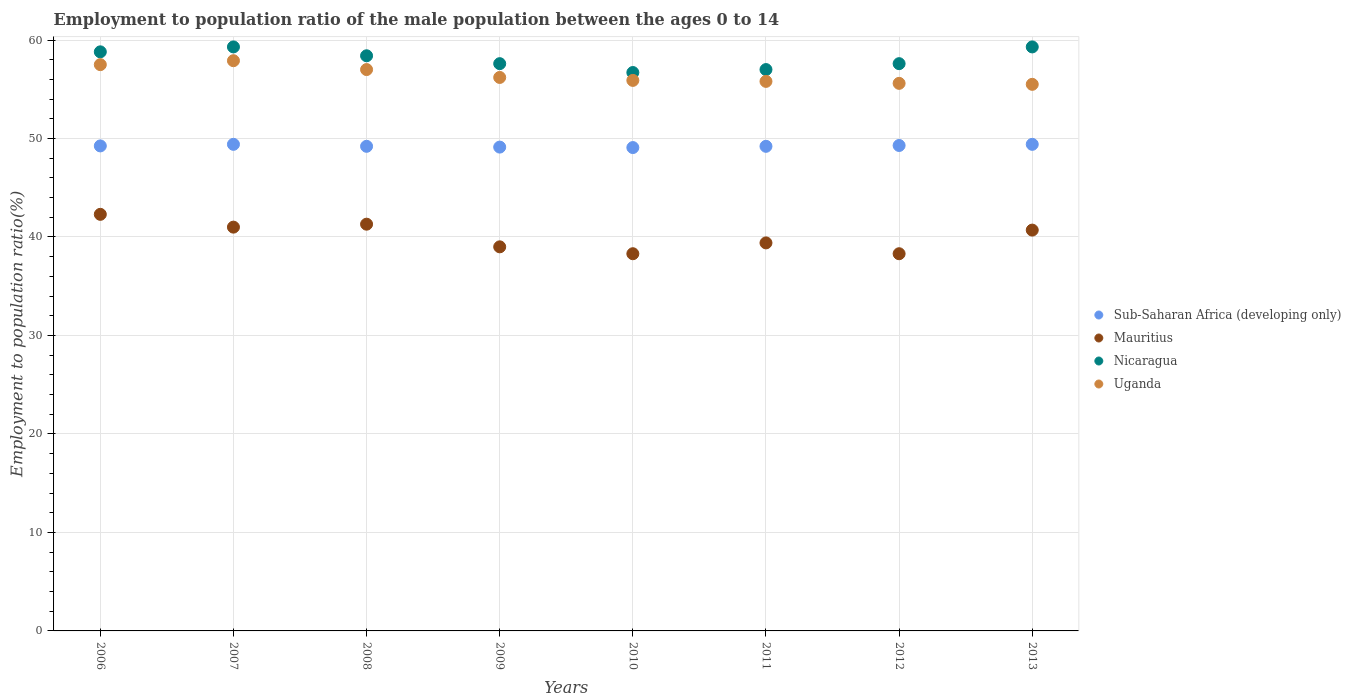Is the number of dotlines equal to the number of legend labels?
Provide a succinct answer. Yes. What is the employment to population ratio in Sub-Saharan Africa (developing only) in 2011?
Provide a short and direct response. 49.21. Across all years, what is the maximum employment to population ratio in Uganda?
Make the answer very short. 57.9. Across all years, what is the minimum employment to population ratio in Uganda?
Offer a terse response. 55.5. In which year was the employment to population ratio in Sub-Saharan Africa (developing only) maximum?
Make the answer very short. 2007. In which year was the employment to population ratio in Mauritius minimum?
Provide a short and direct response. 2010. What is the total employment to population ratio in Sub-Saharan Africa (developing only) in the graph?
Provide a short and direct response. 393.98. What is the difference between the employment to population ratio in Nicaragua in 2007 and that in 2012?
Make the answer very short. 1.7. What is the difference between the employment to population ratio in Uganda in 2010 and the employment to population ratio in Mauritius in 2008?
Provide a short and direct response. 14.6. What is the average employment to population ratio in Mauritius per year?
Your response must be concise. 40.04. In the year 2007, what is the difference between the employment to population ratio in Mauritius and employment to population ratio in Sub-Saharan Africa (developing only)?
Provide a short and direct response. -8.41. What is the ratio of the employment to population ratio in Nicaragua in 2009 to that in 2012?
Your answer should be very brief. 1. Is the employment to population ratio in Mauritius in 2008 less than that in 2013?
Your answer should be compact. No. What is the difference between the highest and the lowest employment to population ratio in Nicaragua?
Your answer should be very brief. 2.6. In how many years, is the employment to population ratio in Mauritius greater than the average employment to population ratio in Mauritius taken over all years?
Make the answer very short. 4. Is it the case that in every year, the sum of the employment to population ratio in Sub-Saharan Africa (developing only) and employment to population ratio in Uganda  is greater than the employment to population ratio in Mauritius?
Your answer should be compact. Yes. Does the employment to population ratio in Nicaragua monotonically increase over the years?
Provide a succinct answer. No. How many years are there in the graph?
Ensure brevity in your answer.  8. Does the graph contain any zero values?
Provide a succinct answer. No. Does the graph contain grids?
Your answer should be very brief. Yes. What is the title of the graph?
Offer a very short reply. Employment to population ratio of the male population between the ages 0 to 14. What is the label or title of the X-axis?
Your answer should be very brief. Years. What is the Employment to population ratio(%) of Sub-Saharan Africa (developing only) in 2006?
Give a very brief answer. 49.25. What is the Employment to population ratio(%) of Mauritius in 2006?
Keep it short and to the point. 42.3. What is the Employment to population ratio(%) in Nicaragua in 2006?
Offer a terse response. 58.8. What is the Employment to population ratio(%) in Uganda in 2006?
Ensure brevity in your answer.  57.5. What is the Employment to population ratio(%) in Sub-Saharan Africa (developing only) in 2007?
Give a very brief answer. 49.41. What is the Employment to population ratio(%) of Nicaragua in 2007?
Offer a very short reply. 59.3. What is the Employment to population ratio(%) of Uganda in 2007?
Give a very brief answer. 57.9. What is the Employment to population ratio(%) of Sub-Saharan Africa (developing only) in 2008?
Provide a short and direct response. 49.21. What is the Employment to population ratio(%) in Mauritius in 2008?
Ensure brevity in your answer.  41.3. What is the Employment to population ratio(%) of Nicaragua in 2008?
Offer a terse response. 58.4. What is the Employment to population ratio(%) of Uganda in 2008?
Your answer should be compact. 57. What is the Employment to population ratio(%) of Sub-Saharan Africa (developing only) in 2009?
Offer a terse response. 49.13. What is the Employment to population ratio(%) in Mauritius in 2009?
Your answer should be very brief. 39. What is the Employment to population ratio(%) of Nicaragua in 2009?
Your response must be concise. 57.6. What is the Employment to population ratio(%) of Uganda in 2009?
Your response must be concise. 56.2. What is the Employment to population ratio(%) of Sub-Saharan Africa (developing only) in 2010?
Give a very brief answer. 49.08. What is the Employment to population ratio(%) of Mauritius in 2010?
Your answer should be very brief. 38.3. What is the Employment to population ratio(%) of Nicaragua in 2010?
Ensure brevity in your answer.  56.7. What is the Employment to population ratio(%) in Uganda in 2010?
Make the answer very short. 55.9. What is the Employment to population ratio(%) in Sub-Saharan Africa (developing only) in 2011?
Provide a succinct answer. 49.21. What is the Employment to population ratio(%) of Mauritius in 2011?
Your response must be concise. 39.4. What is the Employment to population ratio(%) in Nicaragua in 2011?
Offer a very short reply. 57. What is the Employment to population ratio(%) in Uganda in 2011?
Your response must be concise. 55.8. What is the Employment to population ratio(%) in Sub-Saharan Africa (developing only) in 2012?
Keep it short and to the point. 49.29. What is the Employment to population ratio(%) of Mauritius in 2012?
Offer a terse response. 38.3. What is the Employment to population ratio(%) in Nicaragua in 2012?
Provide a succinct answer. 57.6. What is the Employment to population ratio(%) of Uganda in 2012?
Keep it short and to the point. 55.6. What is the Employment to population ratio(%) in Sub-Saharan Africa (developing only) in 2013?
Your response must be concise. 49.41. What is the Employment to population ratio(%) of Mauritius in 2013?
Keep it short and to the point. 40.7. What is the Employment to population ratio(%) in Nicaragua in 2013?
Your response must be concise. 59.3. What is the Employment to population ratio(%) in Uganda in 2013?
Your answer should be compact. 55.5. Across all years, what is the maximum Employment to population ratio(%) in Sub-Saharan Africa (developing only)?
Offer a very short reply. 49.41. Across all years, what is the maximum Employment to population ratio(%) of Mauritius?
Keep it short and to the point. 42.3. Across all years, what is the maximum Employment to population ratio(%) of Nicaragua?
Provide a succinct answer. 59.3. Across all years, what is the maximum Employment to population ratio(%) of Uganda?
Offer a very short reply. 57.9. Across all years, what is the minimum Employment to population ratio(%) in Sub-Saharan Africa (developing only)?
Make the answer very short. 49.08. Across all years, what is the minimum Employment to population ratio(%) of Mauritius?
Offer a terse response. 38.3. Across all years, what is the minimum Employment to population ratio(%) in Nicaragua?
Offer a very short reply. 56.7. Across all years, what is the minimum Employment to population ratio(%) of Uganda?
Keep it short and to the point. 55.5. What is the total Employment to population ratio(%) of Sub-Saharan Africa (developing only) in the graph?
Make the answer very short. 393.98. What is the total Employment to population ratio(%) of Mauritius in the graph?
Provide a succinct answer. 320.3. What is the total Employment to population ratio(%) of Nicaragua in the graph?
Your answer should be very brief. 464.7. What is the total Employment to population ratio(%) of Uganda in the graph?
Provide a succinct answer. 451.4. What is the difference between the Employment to population ratio(%) of Sub-Saharan Africa (developing only) in 2006 and that in 2007?
Make the answer very short. -0.16. What is the difference between the Employment to population ratio(%) of Nicaragua in 2006 and that in 2007?
Ensure brevity in your answer.  -0.5. What is the difference between the Employment to population ratio(%) of Sub-Saharan Africa (developing only) in 2006 and that in 2008?
Keep it short and to the point. 0.04. What is the difference between the Employment to population ratio(%) of Uganda in 2006 and that in 2008?
Give a very brief answer. 0.5. What is the difference between the Employment to population ratio(%) in Sub-Saharan Africa (developing only) in 2006 and that in 2009?
Make the answer very short. 0.12. What is the difference between the Employment to population ratio(%) of Mauritius in 2006 and that in 2009?
Provide a short and direct response. 3.3. What is the difference between the Employment to population ratio(%) in Uganda in 2006 and that in 2009?
Offer a terse response. 1.3. What is the difference between the Employment to population ratio(%) of Sub-Saharan Africa (developing only) in 2006 and that in 2010?
Keep it short and to the point. 0.17. What is the difference between the Employment to population ratio(%) of Mauritius in 2006 and that in 2010?
Your answer should be compact. 4. What is the difference between the Employment to population ratio(%) of Sub-Saharan Africa (developing only) in 2006 and that in 2011?
Offer a terse response. 0.04. What is the difference between the Employment to population ratio(%) of Mauritius in 2006 and that in 2011?
Provide a succinct answer. 2.9. What is the difference between the Employment to population ratio(%) in Nicaragua in 2006 and that in 2011?
Offer a very short reply. 1.8. What is the difference between the Employment to population ratio(%) of Sub-Saharan Africa (developing only) in 2006 and that in 2012?
Your answer should be compact. -0.04. What is the difference between the Employment to population ratio(%) of Mauritius in 2006 and that in 2012?
Your answer should be very brief. 4. What is the difference between the Employment to population ratio(%) of Sub-Saharan Africa (developing only) in 2006 and that in 2013?
Offer a very short reply. -0.16. What is the difference between the Employment to population ratio(%) of Uganda in 2006 and that in 2013?
Offer a very short reply. 2. What is the difference between the Employment to population ratio(%) of Sub-Saharan Africa (developing only) in 2007 and that in 2008?
Make the answer very short. 0.2. What is the difference between the Employment to population ratio(%) in Mauritius in 2007 and that in 2008?
Keep it short and to the point. -0.3. What is the difference between the Employment to population ratio(%) in Nicaragua in 2007 and that in 2008?
Offer a very short reply. 0.9. What is the difference between the Employment to population ratio(%) in Uganda in 2007 and that in 2008?
Offer a very short reply. 0.9. What is the difference between the Employment to population ratio(%) in Sub-Saharan Africa (developing only) in 2007 and that in 2009?
Your answer should be very brief. 0.28. What is the difference between the Employment to population ratio(%) in Sub-Saharan Africa (developing only) in 2007 and that in 2010?
Your answer should be very brief. 0.33. What is the difference between the Employment to population ratio(%) of Mauritius in 2007 and that in 2010?
Provide a short and direct response. 2.7. What is the difference between the Employment to population ratio(%) of Nicaragua in 2007 and that in 2010?
Your answer should be very brief. 2.6. What is the difference between the Employment to population ratio(%) of Sub-Saharan Africa (developing only) in 2007 and that in 2011?
Provide a succinct answer. 0.2. What is the difference between the Employment to population ratio(%) in Uganda in 2007 and that in 2011?
Offer a very short reply. 2.1. What is the difference between the Employment to population ratio(%) of Sub-Saharan Africa (developing only) in 2007 and that in 2012?
Provide a short and direct response. 0.12. What is the difference between the Employment to population ratio(%) of Mauritius in 2007 and that in 2012?
Provide a short and direct response. 2.7. What is the difference between the Employment to population ratio(%) of Nicaragua in 2007 and that in 2012?
Provide a succinct answer. 1.7. What is the difference between the Employment to population ratio(%) of Sub-Saharan Africa (developing only) in 2007 and that in 2013?
Give a very brief answer. 0. What is the difference between the Employment to population ratio(%) in Sub-Saharan Africa (developing only) in 2008 and that in 2009?
Your response must be concise. 0.08. What is the difference between the Employment to population ratio(%) of Mauritius in 2008 and that in 2009?
Offer a very short reply. 2.3. What is the difference between the Employment to population ratio(%) in Nicaragua in 2008 and that in 2009?
Make the answer very short. 0.8. What is the difference between the Employment to population ratio(%) of Sub-Saharan Africa (developing only) in 2008 and that in 2010?
Provide a succinct answer. 0.13. What is the difference between the Employment to population ratio(%) of Mauritius in 2008 and that in 2010?
Provide a succinct answer. 3. What is the difference between the Employment to population ratio(%) in Sub-Saharan Africa (developing only) in 2008 and that in 2011?
Keep it short and to the point. 0. What is the difference between the Employment to population ratio(%) of Mauritius in 2008 and that in 2011?
Keep it short and to the point. 1.9. What is the difference between the Employment to population ratio(%) of Nicaragua in 2008 and that in 2011?
Keep it short and to the point. 1.4. What is the difference between the Employment to population ratio(%) of Sub-Saharan Africa (developing only) in 2008 and that in 2012?
Offer a terse response. -0.08. What is the difference between the Employment to population ratio(%) in Sub-Saharan Africa (developing only) in 2008 and that in 2013?
Ensure brevity in your answer.  -0.2. What is the difference between the Employment to population ratio(%) in Mauritius in 2008 and that in 2013?
Provide a short and direct response. 0.6. What is the difference between the Employment to population ratio(%) in Nicaragua in 2008 and that in 2013?
Give a very brief answer. -0.9. What is the difference between the Employment to population ratio(%) in Uganda in 2008 and that in 2013?
Offer a very short reply. 1.5. What is the difference between the Employment to population ratio(%) in Sub-Saharan Africa (developing only) in 2009 and that in 2010?
Ensure brevity in your answer.  0.05. What is the difference between the Employment to population ratio(%) of Mauritius in 2009 and that in 2010?
Make the answer very short. 0.7. What is the difference between the Employment to population ratio(%) of Sub-Saharan Africa (developing only) in 2009 and that in 2011?
Your answer should be very brief. -0.08. What is the difference between the Employment to population ratio(%) in Mauritius in 2009 and that in 2011?
Ensure brevity in your answer.  -0.4. What is the difference between the Employment to population ratio(%) in Nicaragua in 2009 and that in 2011?
Keep it short and to the point. 0.6. What is the difference between the Employment to population ratio(%) in Sub-Saharan Africa (developing only) in 2009 and that in 2012?
Your response must be concise. -0.16. What is the difference between the Employment to population ratio(%) in Mauritius in 2009 and that in 2012?
Offer a very short reply. 0.7. What is the difference between the Employment to population ratio(%) in Nicaragua in 2009 and that in 2012?
Give a very brief answer. 0. What is the difference between the Employment to population ratio(%) of Sub-Saharan Africa (developing only) in 2009 and that in 2013?
Your answer should be compact. -0.28. What is the difference between the Employment to population ratio(%) in Nicaragua in 2009 and that in 2013?
Ensure brevity in your answer.  -1.7. What is the difference between the Employment to population ratio(%) of Uganda in 2009 and that in 2013?
Your answer should be very brief. 0.7. What is the difference between the Employment to population ratio(%) of Sub-Saharan Africa (developing only) in 2010 and that in 2011?
Provide a short and direct response. -0.13. What is the difference between the Employment to population ratio(%) of Mauritius in 2010 and that in 2011?
Provide a short and direct response. -1.1. What is the difference between the Employment to population ratio(%) of Nicaragua in 2010 and that in 2011?
Provide a succinct answer. -0.3. What is the difference between the Employment to population ratio(%) of Uganda in 2010 and that in 2011?
Provide a short and direct response. 0.1. What is the difference between the Employment to population ratio(%) in Sub-Saharan Africa (developing only) in 2010 and that in 2012?
Your answer should be very brief. -0.21. What is the difference between the Employment to population ratio(%) of Mauritius in 2010 and that in 2012?
Provide a succinct answer. 0. What is the difference between the Employment to population ratio(%) in Nicaragua in 2010 and that in 2012?
Provide a short and direct response. -0.9. What is the difference between the Employment to population ratio(%) in Sub-Saharan Africa (developing only) in 2010 and that in 2013?
Give a very brief answer. -0.33. What is the difference between the Employment to population ratio(%) of Mauritius in 2010 and that in 2013?
Your answer should be compact. -2.4. What is the difference between the Employment to population ratio(%) of Nicaragua in 2010 and that in 2013?
Ensure brevity in your answer.  -2.6. What is the difference between the Employment to population ratio(%) in Sub-Saharan Africa (developing only) in 2011 and that in 2012?
Make the answer very short. -0.08. What is the difference between the Employment to population ratio(%) in Mauritius in 2011 and that in 2012?
Offer a terse response. 1.1. What is the difference between the Employment to population ratio(%) of Nicaragua in 2011 and that in 2012?
Make the answer very short. -0.6. What is the difference between the Employment to population ratio(%) of Sub-Saharan Africa (developing only) in 2011 and that in 2013?
Keep it short and to the point. -0.2. What is the difference between the Employment to population ratio(%) of Mauritius in 2011 and that in 2013?
Your answer should be very brief. -1.3. What is the difference between the Employment to population ratio(%) of Nicaragua in 2011 and that in 2013?
Make the answer very short. -2.3. What is the difference between the Employment to population ratio(%) in Uganda in 2011 and that in 2013?
Ensure brevity in your answer.  0.3. What is the difference between the Employment to population ratio(%) in Sub-Saharan Africa (developing only) in 2012 and that in 2013?
Offer a terse response. -0.12. What is the difference between the Employment to population ratio(%) in Nicaragua in 2012 and that in 2013?
Your answer should be compact. -1.7. What is the difference between the Employment to population ratio(%) in Uganda in 2012 and that in 2013?
Ensure brevity in your answer.  0.1. What is the difference between the Employment to population ratio(%) in Sub-Saharan Africa (developing only) in 2006 and the Employment to population ratio(%) in Mauritius in 2007?
Offer a terse response. 8.25. What is the difference between the Employment to population ratio(%) in Sub-Saharan Africa (developing only) in 2006 and the Employment to population ratio(%) in Nicaragua in 2007?
Make the answer very short. -10.05. What is the difference between the Employment to population ratio(%) of Sub-Saharan Africa (developing only) in 2006 and the Employment to population ratio(%) of Uganda in 2007?
Give a very brief answer. -8.65. What is the difference between the Employment to population ratio(%) in Mauritius in 2006 and the Employment to population ratio(%) in Uganda in 2007?
Provide a short and direct response. -15.6. What is the difference between the Employment to population ratio(%) of Nicaragua in 2006 and the Employment to population ratio(%) of Uganda in 2007?
Your answer should be compact. 0.9. What is the difference between the Employment to population ratio(%) of Sub-Saharan Africa (developing only) in 2006 and the Employment to population ratio(%) of Mauritius in 2008?
Ensure brevity in your answer.  7.95. What is the difference between the Employment to population ratio(%) of Sub-Saharan Africa (developing only) in 2006 and the Employment to population ratio(%) of Nicaragua in 2008?
Your response must be concise. -9.15. What is the difference between the Employment to population ratio(%) in Sub-Saharan Africa (developing only) in 2006 and the Employment to population ratio(%) in Uganda in 2008?
Your answer should be very brief. -7.75. What is the difference between the Employment to population ratio(%) of Mauritius in 2006 and the Employment to population ratio(%) of Nicaragua in 2008?
Offer a terse response. -16.1. What is the difference between the Employment to population ratio(%) of Mauritius in 2006 and the Employment to population ratio(%) of Uganda in 2008?
Give a very brief answer. -14.7. What is the difference between the Employment to population ratio(%) of Nicaragua in 2006 and the Employment to population ratio(%) of Uganda in 2008?
Your answer should be compact. 1.8. What is the difference between the Employment to population ratio(%) of Sub-Saharan Africa (developing only) in 2006 and the Employment to population ratio(%) of Mauritius in 2009?
Your answer should be compact. 10.25. What is the difference between the Employment to population ratio(%) of Sub-Saharan Africa (developing only) in 2006 and the Employment to population ratio(%) of Nicaragua in 2009?
Offer a terse response. -8.35. What is the difference between the Employment to population ratio(%) of Sub-Saharan Africa (developing only) in 2006 and the Employment to population ratio(%) of Uganda in 2009?
Keep it short and to the point. -6.95. What is the difference between the Employment to population ratio(%) in Mauritius in 2006 and the Employment to population ratio(%) in Nicaragua in 2009?
Ensure brevity in your answer.  -15.3. What is the difference between the Employment to population ratio(%) of Nicaragua in 2006 and the Employment to population ratio(%) of Uganda in 2009?
Offer a terse response. 2.6. What is the difference between the Employment to population ratio(%) of Sub-Saharan Africa (developing only) in 2006 and the Employment to population ratio(%) of Mauritius in 2010?
Your answer should be compact. 10.95. What is the difference between the Employment to population ratio(%) in Sub-Saharan Africa (developing only) in 2006 and the Employment to population ratio(%) in Nicaragua in 2010?
Ensure brevity in your answer.  -7.45. What is the difference between the Employment to population ratio(%) in Sub-Saharan Africa (developing only) in 2006 and the Employment to population ratio(%) in Uganda in 2010?
Provide a succinct answer. -6.65. What is the difference between the Employment to population ratio(%) in Mauritius in 2006 and the Employment to population ratio(%) in Nicaragua in 2010?
Offer a very short reply. -14.4. What is the difference between the Employment to population ratio(%) in Sub-Saharan Africa (developing only) in 2006 and the Employment to population ratio(%) in Mauritius in 2011?
Offer a very short reply. 9.85. What is the difference between the Employment to population ratio(%) in Sub-Saharan Africa (developing only) in 2006 and the Employment to population ratio(%) in Nicaragua in 2011?
Offer a terse response. -7.75. What is the difference between the Employment to population ratio(%) in Sub-Saharan Africa (developing only) in 2006 and the Employment to population ratio(%) in Uganda in 2011?
Provide a succinct answer. -6.55. What is the difference between the Employment to population ratio(%) of Mauritius in 2006 and the Employment to population ratio(%) of Nicaragua in 2011?
Keep it short and to the point. -14.7. What is the difference between the Employment to population ratio(%) of Nicaragua in 2006 and the Employment to population ratio(%) of Uganda in 2011?
Your answer should be very brief. 3. What is the difference between the Employment to population ratio(%) of Sub-Saharan Africa (developing only) in 2006 and the Employment to population ratio(%) of Mauritius in 2012?
Provide a succinct answer. 10.95. What is the difference between the Employment to population ratio(%) of Sub-Saharan Africa (developing only) in 2006 and the Employment to population ratio(%) of Nicaragua in 2012?
Make the answer very short. -8.35. What is the difference between the Employment to population ratio(%) of Sub-Saharan Africa (developing only) in 2006 and the Employment to population ratio(%) of Uganda in 2012?
Offer a very short reply. -6.35. What is the difference between the Employment to population ratio(%) in Mauritius in 2006 and the Employment to population ratio(%) in Nicaragua in 2012?
Your answer should be very brief. -15.3. What is the difference between the Employment to population ratio(%) of Sub-Saharan Africa (developing only) in 2006 and the Employment to population ratio(%) of Mauritius in 2013?
Provide a short and direct response. 8.55. What is the difference between the Employment to population ratio(%) in Sub-Saharan Africa (developing only) in 2006 and the Employment to population ratio(%) in Nicaragua in 2013?
Give a very brief answer. -10.05. What is the difference between the Employment to population ratio(%) in Sub-Saharan Africa (developing only) in 2006 and the Employment to population ratio(%) in Uganda in 2013?
Offer a very short reply. -6.25. What is the difference between the Employment to population ratio(%) in Mauritius in 2006 and the Employment to population ratio(%) in Uganda in 2013?
Make the answer very short. -13.2. What is the difference between the Employment to population ratio(%) in Sub-Saharan Africa (developing only) in 2007 and the Employment to population ratio(%) in Mauritius in 2008?
Offer a very short reply. 8.11. What is the difference between the Employment to population ratio(%) of Sub-Saharan Africa (developing only) in 2007 and the Employment to population ratio(%) of Nicaragua in 2008?
Provide a short and direct response. -8.99. What is the difference between the Employment to population ratio(%) in Sub-Saharan Africa (developing only) in 2007 and the Employment to population ratio(%) in Uganda in 2008?
Offer a terse response. -7.59. What is the difference between the Employment to population ratio(%) in Mauritius in 2007 and the Employment to population ratio(%) in Nicaragua in 2008?
Make the answer very short. -17.4. What is the difference between the Employment to population ratio(%) of Sub-Saharan Africa (developing only) in 2007 and the Employment to population ratio(%) of Mauritius in 2009?
Offer a terse response. 10.41. What is the difference between the Employment to population ratio(%) in Sub-Saharan Africa (developing only) in 2007 and the Employment to population ratio(%) in Nicaragua in 2009?
Make the answer very short. -8.19. What is the difference between the Employment to population ratio(%) of Sub-Saharan Africa (developing only) in 2007 and the Employment to population ratio(%) of Uganda in 2009?
Keep it short and to the point. -6.79. What is the difference between the Employment to population ratio(%) in Mauritius in 2007 and the Employment to population ratio(%) in Nicaragua in 2009?
Offer a terse response. -16.6. What is the difference between the Employment to population ratio(%) of Mauritius in 2007 and the Employment to population ratio(%) of Uganda in 2009?
Your response must be concise. -15.2. What is the difference between the Employment to population ratio(%) in Sub-Saharan Africa (developing only) in 2007 and the Employment to population ratio(%) in Mauritius in 2010?
Keep it short and to the point. 11.11. What is the difference between the Employment to population ratio(%) in Sub-Saharan Africa (developing only) in 2007 and the Employment to population ratio(%) in Nicaragua in 2010?
Make the answer very short. -7.29. What is the difference between the Employment to population ratio(%) in Sub-Saharan Africa (developing only) in 2007 and the Employment to population ratio(%) in Uganda in 2010?
Give a very brief answer. -6.49. What is the difference between the Employment to population ratio(%) in Mauritius in 2007 and the Employment to population ratio(%) in Nicaragua in 2010?
Your answer should be very brief. -15.7. What is the difference between the Employment to population ratio(%) in Mauritius in 2007 and the Employment to population ratio(%) in Uganda in 2010?
Provide a succinct answer. -14.9. What is the difference between the Employment to population ratio(%) in Sub-Saharan Africa (developing only) in 2007 and the Employment to population ratio(%) in Mauritius in 2011?
Your answer should be very brief. 10.01. What is the difference between the Employment to population ratio(%) in Sub-Saharan Africa (developing only) in 2007 and the Employment to population ratio(%) in Nicaragua in 2011?
Your answer should be very brief. -7.59. What is the difference between the Employment to population ratio(%) of Sub-Saharan Africa (developing only) in 2007 and the Employment to population ratio(%) of Uganda in 2011?
Your answer should be very brief. -6.39. What is the difference between the Employment to population ratio(%) of Mauritius in 2007 and the Employment to population ratio(%) of Uganda in 2011?
Keep it short and to the point. -14.8. What is the difference between the Employment to population ratio(%) of Sub-Saharan Africa (developing only) in 2007 and the Employment to population ratio(%) of Mauritius in 2012?
Offer a very short reply. 11.11. What is the difference between the Employment to population ratio(%) of Sub-Saharan Africa (developing only) in 2007 and the Employment to population ratio(%) of Nicaragua in 2012?
Offer a terse response. -8.19. What is the difference between the Employment to population ratio(%) in Sub-Saharan Africa (developing only) in 2007 and the Employment to population ratio(%) in Uganda in 2012?
Your answer should be compact. -6.19. What is the difference between the Employment to population ratio(%) of Mauritius in 2007 and the Employment to population ratio(%) of Nicaragua in 2012?
Offer a terse response. -16.6. What is the difference between the Employment to population ratio(%) in Mauritius in 2007 and the Employment to population ratio(%) in Uganda in 2012?
Your answer should be compact. -14.6. What is the difference between the Employment to population ratio(%) of Nicaragua in 2007 and the Employment to population ratio(%) of Uganda in 2012?
Your response must be concise. 3.7. What is the difference between the Employment to population ratio(%) in Sub-Saharan Africa (developing only) in 2007 and the Employment to population ratio(%) in Mauritius in 2013?
Give a very brief answer. 8.71. What is the difference between the Employment to population ratio(%) in Sub-Saharan Africa (developing only) in 2007 and the Employment to population ratio(%) in Nicaragua in 2013?
Ensure brevity in your answer.  -9.89. What is the difference between the Employment to population ratio(%) in Sub-Saharan Africa (developing only) in 2007 and the Employment to population ratio(%) in Uganda in 2013?
Keep it short and to the point. -6.09. What is the difference between the Employment to population ratio(%) of Mauritius in 2007 and the Employment to population ratio(%) of Nicaragua in 2013?
Your answer should be compact. -18.3. What is the difference between the Employment to population ratio(%) in Mauritius in 2007 and the Employment to population ratio(%) in Uganda in 2013?
Give a very brief answer. -14.5. What is the difference between the Employment to population ratio(%) of Sub-Saharan Africa (developing only) in 2008 and the Employment to population ratio(%) of Mauritius in 2009?
Your answer should be very brief. 10.21. What is the difference between the Employment to population ratio(%) of Sub-Saharan Africa (developing only) in 2008 and the Employment to population ratio(%) of Nicaragua in 2009?
Provide a short and direct response. -8.39. What is the difference between the Employment to population ratio(%) in Sub-Saharan Africa (developing only) in 2008 and the Employment to population ratio(%) in Uganda in 2009?
Offer a terse response. -6.99. What is the difference between the Employment to population ratio(%) in Mauritius in 2008 and the Employment to population ratio(%) in Nicaragua in 2009?
Keep it short and to the point. -16.3. What is the difference between the Employment to population ratio(%) of Mauritius in 2008 and the Employment to population ratio(%) of Uganda in 2009?
Make the answer very short. -14.9. What is the difference between the Employment to population ratio(%) in Sub-Saharan Africa (developing only) in 2008 and the Employment to population ratio(%) in Mauritius in 2010?
Offer a terse response. 10.91. What is the difference between the Employment to population ratio(%) of Sub-Saharan Africa (developing only) in 2008 and the Employment to population ratio(%) of Nicaragua in 2010?
Offer a very short reply. -7.49. What is the difference between the Employment to population ratio(%) of Sub-Saharan Africa (developing only) in 2008 and the Employment to population ratio(%) of Uganda in 2010?
Provide a succinct answer. -6.69. What is the difference between the Employment to population ratio(%) of Mauritius in 2008 and the Employment to population ratio(%) of Nicaragua in 2010?
Give a very brief answer. -15.4. What is the difference between the Employment to population ratio(%) in Mauritius in 2008 and the Employment to population ratio(%) in Uganda in 2010?
Ensure brevity in your answer.  -14.6. What is the difference between the Employment to population ratio(%) of Nicaragua in 2008 and the Employment to population ratio(%) of Uganda in 2010?
Your answer should be very brief. 2.5. What is the difference between the Employment to population ratio(%) in Sub-Saharan Africa (developing only) in 2008 and the Employment to population ratio(%) in Mauritius in 2011?
Ensure brevity in your answer.  9.81. What is the difference between the Employment to population ratio(%) in Sub-Saharan Africa (developing only) in 2008 and the Employment to population ratio(%) in Nicaragua in 2011?
Keep it short and to the point. -7.79. What is the difference between the Employment to population ratio(%) of Sub-Saharan Africa (developing only) in 2008 and the Employment to population ratio(%) of Uganda in 2011?
Give a very brief answer. -6.59. What is the difference between the Employment to population ratio(%) in Mauritius in 2008 and the Employment to population ratio(%) in Nicaragua in 2011?
Provide a short and direct response. -15.7. What is the difference between the Employment to population ratio(%) of Mauritius in 2008 and the Employment to population ratio(%) of Uganda in 2011?
Keep it short and to the point. -14.5. What is the difference between the Employment to population ratio(%) of Sub-Saharan Africa (developing only) in 2008 and the Employment to population ratio(%) of Mauritius in 2012?
Ensure brevity in your answer.  10.91. What is the difference between the Employment to population ratio(%) in Sub-Saharan Africa (developing only) in 2008 and the Employment to population ratio(%) in Nicaragua in 2012?
Your answer should be very brief. -8.39. What is the difference between the Employment to population ratio(%) of Sub-Saharan Africa (developing only) in 2008 and the Employment to population ratio(%) of Uganda in 2012?
Your answer should be compact. -6.39. What is the difference between the Employment to population ratio(%) in Mauritius in 2008 and the Employment to population ratio(%) in Nicaragua in 2012?
Offer a very short reply. -16.3. What is the difference between the Employment to population ratio(%) of Mauritius in 2008 and the Employment to population ratio(%) of Uganda in 2012?
Offer a terse response. -14.3. What is the difference between the Employment to population ratio(%) of Sub-Saharan Africa (developing only) in 2008 and the Employment to population ratio(%) of Mauritius in 2013?
Provide a short and direct response. 8.51. What is the difference between the Employment to population ratio(%) of Sub-Saharan Africa (developing only) in 2008 and the Employment to population ratio(%) of Nicaragua in 2013?
Your answer should be compact. -10.09. What is the difference between the Employment to population ratio(%) of Sub-Saharan Africa (developing only) in 2008 and the Employment to population ratio(%) of Uganda in 2013?
Provide a succinct answer. -6.29. What is the difference between the Employment to population ratio(%) of Sub-Saharan Africa (developing only) in 2009 and the Employment to population ratio(%) of Mauritius in 2010?
Your answer should be compact. 10.83. What is the difference between the Employment to population ratio(%) in Sub-Saharan Africa (developing only) in 2009 and the Employment to population ratio(%) in Nicaragua in 2010?
Offer a very short reply. -7.57. What is the difference between the Employment to population ratio(%) of Sub-Saharan Africa (developing only) in 2009 and the Employment to population ratio(%) of Uganda in 2010?
Offer a very short reply. -6.77. What is the difference between the Employment to population ratio(%) of Mauritius in 2009 and the Employment to population ratio(%) of Nicaragua in 2010?
Ensure brevity in your answer.  -17.7. What is the difference between the Employment to population ratio(%) of Mauritius in 2009 and the Employment to population ratio(%) of Uganda in 2010?
Make the answer very short. -16.9. What is the difference between the Employment to population ratio(%) of Sub-Saharan Africa (developing only) in 2009 and the Employment to population ratio(%) of Mauritius in 2011?
Keep it short and to the point. 9.73. What is the difference between the Employment to population ratio(%) of Sub-Saharan Africa (developing only) in 2009 and the Employment to population ratio(%) of Nicaragua in 2011?
Give a very brief answer. -7.87. What is the difference between the Employment to population ratio(%) in Sub-Saharan Africa (developing only) in 2009 and the Employment to population ratio(%) in Uganda in 2011?
Offer a terse response. -6.67. What is the difference between the Employment to population ratio(%) of Mauritius in 2009 and the Employment to population ratio(%) of Uganda in 2011?
Provide a short and direct response. -16.8. What is the difference between the Employment to population ratio(%) of Sub-Saharan Africa (developing only) in 2009 and the Employment to population ratio(%) of Mauritius in 2012?
Ensure brevity in your answer.  10.83. What is the difference between the Employment to population ratio(%) of Sub-Saharan Africa (developing only) in 2009 and the Employment to population ratio(%) of Nicaragua in 2012?
Make the answer very short. -8.47. What is the difference between the Employment to population ratio(%) in Sub-Saharan Africa (developing only) in 2009 and the Employment to population ratio(%) in Uganda in 2012?
Provide a succinct answer. -6.47. What is the difference between the Employment to population ratio(%) of Mauritius in 2009 and the Employment to population ratio(%) of Nicaragua in 2012?
Make the answer very short. -18.6. What is the difference between the Employment to population ratio(%) in Mauritius in 2009 and the Employment to population ratio(%) in Uganda in 2012?
Your answer should be compact. -16.6. What is the difference between the Employment to population ratio(%) of Sub-Saharan Africa (developing only) in 2009 and the Employment to population ratio(%) of Mauritius in 2013?
Ensure brevity in your answer.  8.43. What is the difference between the Employment to population ratio(%) in Sub-Saharan Africa (developing only) in 2009 and the Employment to population ratio(%) in Nicaragua in 2013?
Make the answer very short. -10.17. What is the difference between the Employment to population ratio(%) of Sub-Saharan Africa (developing only) in 2009 and the Employment to population ratio(%) of Uganda in 2013?
Provide a short and direct response. -6.37. What is the difference between the Employment to population ratio(%) in Mauritius in 2009 and the Employment to population ratio(%) in Nicaragua in 2013?
Give a very brief answer. -20.3. What is the difference between the Employment to population ratio(%) of Mauritius in 2009 and the Employment to population ratio(%) of Uganda in 2013?
Make the answer very short. -16.5. What is the difference between the Employment to population ratio(%) in Sub-Saharan Africa (developing only) in 2010 and the Employment to population ratio(%) in Mauritius in 2011?
Make the answer very short. 9.68. What is the difference between the Employment to population ratio(%) in Sub-Saharan Africa (developing only) in 2010 and the Employment to population ratio(%) in Nicaragua in 2011?
Your answer should be very brief. -7.92. What is the difference between the Employment to population ratio(%) in Sub-Saharan Africa (developing only) in 2010 and the Employment to population ratio(%) in Uganda in 2011?
Make the answer very short. -6.72. What is the difference between the Employment to population ratio(%) of Mauritius in 2010 and the Employment to population ratio(%) of Nicaragua in 2011?
Your answer should be very brief. -18.7. What is the difference between the Employment to population ratio(%) of Mauritius in 2010 and the Employment to population ratio(%) of Uganda in 2011?
Offer a terse response. -17.5. What is the difference between the Employment to population ratio(%) of Sub-Saharan Africa (developing only) in 2010 and the Employment to population ratio(%) of Mauritius in 2012?
Give a very brief answer. 10.78. What is the difference between the Employment to population ratio(%) of Sub-Saharan Africa (developing only) in 2010 and the Employment to population ratio(%) of Nicaragua in 2012?
Your answer should be compact. -8.52. What is the difference between the Employment to population ratio(%) of Sub-Saharan Africa (developing only) in 2010 and the Employment to population ratio(%) of Uganda in 2012?
Ensure brevity in your answer.  -6.52. What is the difference between the Employment to population ratio(%) in Mauritius in 2010 and the Employment to population ratio(%) in Nicaragua in 2012?
Your answer should be compact. -19.3. What is the difference between the Employment to population ratio(%) of Mauritius in 2010 and the Employment to population ratio(%) of Uganda in 2012?
Your response must be concise. -17.3. What is the difference between the Employment to population ratio(%) in Sub-Saharan Africa (developing only) in 2010 and the Employment to population ratio(%) in Mauritius in 2013?
Keep it short and to the point. 8.38. What is the difference between the Employment to population ratio(%) of Sub-Saharan Africa (developing only) in 2010 and the Employment to population ratio(%) of Nicaragua in 2013?
Keep it short and to the point. -10.22. What is the difference between the Employment to population ratio(%) in Sub-Saharan Africa (developing only) in 2010 and the Employment to population ratio(%) in Uganda in 2013?
Offer a very short reply. -6.42. What is the difference between the Employment to population ratio(%) in Mauritius in 2010 and the Employment to population ratio(%) in Nicaragua in 2013?
Offer a terse response. -21. What is the difference between the Employment to population ratio(%) of Mauritius in 2010 and the Employment to population ratio(%) of Uganda in 2013?
Make the answer very short. -17.2. What is the difference between the Employment to population ratio(%) of Sub-Saharan Africa (developing only) in 2011 and the Employment to population ratio(%) of Mauritius in 2012?
Your response must be concise. 10.91. What is the difference between the Employment to population ratio(%) of Sub-Saharan Africa (developing only) in 2011 and the Employment to population ratio(%) of Nicaragua in 2012?
Your answer should be compact. -8.39. What is the difference between the Employment to population ratio(%) in Sub-Saharan Africa (developing only) in 2011 and the Employment to population ratio(%) in Uganda in 2012?
Your answer should be compact. -6.39. What is the difference between the Employment to population ratio(%) of Mauritius in 2011 and the Employment to population ratio(%) of Nicaragua in 2012?
Make the answer very short. -18.2. What is the difference between the Employment to population ratio(%) of Mauritius in 2011 and the Employment to population ratio(%) of Uganda in 2012?
Ensure brevity in your answer.  -16.2. What is the difference between the Employment to population ratio(%) in Nicaragua in 2011 and the Employment to population ratio(%) in Uganda in 2012?
Make the answer very short. 1.4. What is the difference between the Employment to population ratio(%) of Sub-Saharan Africa (developing only) in 2011 and the Employment to population ratio(%) of Mauritius in 2013?
Provide a short and direct response. 8.51. What is the difference between the Employment to population ratio(%) of Sub-Saharan Africa (developing only) in 2011 and the Employment to population ratio(%) of Nicaragua in 2013?
Give a very brief answer. -10.09. What is the difference between the Employment to population ratio(%) of Sub-Saharan Africa (developing only) in 2011 and the Employment to population ratio(%) of Uganda in 2013?
Your response must be concise. -6.29. What is the difference between the Employment to population ratio(%) in Mauritius in 2011 and the Employment to population ratio(%) in Nicaragua in 2013?
Provide a short and direct response. -19.9. What is the difference between the Employment to population ratio(%) in Mauritius in 2011 and the Employment to population ratio(%) in Uganda in 2013?
Provide a succinct answer. -16.1. What is the difference between the Employment to population ratio(%) in Nicaragua in 2011 and the Employment to population ratio(%) in Uganda in 2013?
Make the answer very short. 1.5. What is the difference between the Employment to population ratio(%) in Sub-Saharan Africa (developing only) in 2012 and the Employment to population ratio(%) in Mauritius in 2013?
Offer a very short reply. 8.59. What is the difference between the Employment to population ratio(%) of Sub-Saharan Africa (developing only) in 2012 and the Employment to population ratio(%) of Nicaragua in 2013?
Your answer should be very brief. -10.01. What is the difference between the Employment to population ratio(%) in Sub-Saharan Africa (developing only) in 2012 and the Employment to population ratio(%) in Uganda in 2013?
Offer a terse response. -6.21. What is the difference between the Employment to population ratio(%) of Mauritius in 2012 and the Employment to population ratio(%) of Uganda in 2013?
Your answer should be very brief. -17.2. What is the difference between the Employment to population ratio(%) in Nicaragua in 2012 and the Employment to population ratio(%) in Uganda in 2013?
Offer a very short reply. 2.1. What is the average Employment to population ratio(%) in Sub-Saharan Africa (developing only) per year?
Provide a short and direct response. 49.25. What is the average Employment to population ratio(%) in Mauritius per year?
Your answer should be compact. 40.04. What is the average Employment to population ratio(%) in Nicaragua per year?
Make the answer very short. 58.09. What is the average Employment to population ratio(%) in Uganda per year?
Offer a terse response. 56.42. In the year 2006, what is the difference between the Employment to population ratio(%) in Sub-Saharan Africa (developing only) and Employment to population ratio(%) in Mauritius?
Ensure brevity in your answer.  6.95. In the year 2006, what is the difference between the Employment to population ratio(%) of Sub-Saharan Africa (developing only) and Employment to population ratio(%) of Nicaragua?
Your answer should be compact. -9.55. In the year 2006, what is the difference between the Employment to population ratio(%) in Sub-Saharan Africa (developing only) and Employment to population ratio(%) in Uganda?
Provide a succinct answer. -8.25. In the year 2006, what is the difference between the Employment to population ratio(%) in Mauritius and Employment to population ratio(%) in Nicaragua?
Offer a terse response. -16.5. In the year 2006, what is the difference between the Employment to population ratio(%) of Mauritius and Employment to population ratio(%) of Uganda?
Provide a succinct answer. -15.2. In the year 2007, what is the difference between the Employment to population ratio(%) in Sub-Saharan Africa (developing only) and Employment to population ratio(%) in Mauritius?
Offer a very short reply. 8.41. In the year 2007, what is the difference between the Employment to population ratio(%) of Sub-Saharan Africa (developing only) and Employment to population ratio(%) of Nicaragua?
Provide a succinct answer. -9.89. In the year 2007, what is the difference between the Employment to population ratio(%) in Sub-Saharan Africa (developing only) and Employment to population ratio(%) in Uganda?
Keep it short and to the point. -8.49. In the year 2007, what is the difference between the Employment to population ratio(%) of Mauritius and Employment to population ratio(%) of Nicaragua?
Give a very brief answer. -18.3. In the year 2007, what is the difference between the Employment to population ratio(%) in Mauritius and Employment to population ratio(%) in Uganda?
Offer a terse response. -16.9. In the year 2008, what is the difference between the Employment to population ratio(%) in Sub-Saharan Africa (developing only) and Employment to population ratio(%) in Mauritius?
Keep it short and to the point. 7.91. In the year 2008, what is the difference between the Employment to population ratio(%) in Sub-Saharan Africa (developing only) and Employment to population ratio(%) in Nicaragua?
Offer a very short reply. -9.19. In the year 2008, what is the difference between the Employment to population ratio(%) in Sub-Saharan Africa (developing only) and Employment to population ratio(%) in Uganda?
Your answer should be compact. -7.79. In the year 2008, what is the difference between the Employment to population ratio(%) of Mauritius and Employment to population ratio(%) of Nicaragua?
Provide a succinct answer. -17.1. In the year 2008, what is the difference between the Employment to population ratio(%) in Mauritius and Employment to population ratio(%) in Uganda?
Provide a short and direct response. -15.7. In the year 2009, what is the difference between the Employment to population ratio(%) of Sub-Saharan Africa (developing only) and Employment to population ratio(%) of Mauritius?
Your response must be concise. 10.13. In the year 2009, what is the difference between the Employment to population ratio(%) of Sub-Saharan Africa (developing only) and Employment to population ratio(%) of Nicaragua?
Your response must be concise. -8.47. In the year 2009, what is the difference between the Employment to population ratio(%) of Sub-Saharan Africa (developing only) and Employment to population ratio(%) of Uganda?
Keep it short and to the point. -7.07. In the year 2009, what is the difference between the Employment to population ratio(%) of Mauritius and Employment to population ratio(%) of Nicaragua?
Provide a succinct answer. -18.6. In the year 2009, what is the difference between the Employment to population ratio(%) of Mauritius and Employment to population ratio(%) of Uganda?
Your answer should be compact. -17.2. In the year 2010, what is the difference between the Employment to population ratio(%) in Sub-Saharan Africa (developing only) and Employment to population ratio(%) in Mauritius?
Give a very brief answer. 10.78. In the year 2010, what is the difference between the Employment to population ratio(%) in Sub-Saharan Africa (developing only) and Employment to population ratio(%) in Nicaragua?
Your answer should be very brief. -7.62. In the year 2010, what is the difference between the Employment to population ratio(%) in Sub-Saharan Africa (developing only) and Employment to population ratio(%) in Uganda?
Offer a terse response. -6.82. In the year 2010, what is the difference between the Employment to population ratio(%) in Mauritius and Employment to population ratio(%) in Nicaragua?
Make the answer very short. -18.4. In the year 2010, what is the difference between the Employment to population ratio(%) in Mauritius and Employment to population ratio(%) in Uganda?
Your response must be concise. -17.6. In the year 2010, what is the difference between the Employment to population ratio(%) in Nicaragua and Employment to population ratio(%) in Uganda?
Offer a terse response. 0.8. In the year 2011, what is the difference between the Employment to population ratio(%) in Sub-Saharan Africa (developing only) and Employment to population ratio(%) in Mauritius?
Keep it short and to the point. 9.81. In the year 2011, what is the difference between the Employment to population ratio(%) in Sub-Saharan Africa (developing only) and Employment to population ratio(%) in Nicaragua?
Offer a terse response. -7.79. In the year 2011, what is the difference between the Employment to population ratio(%) of Sub-Saharan Africa (developing only) and Employment to population ratio(%) of Uganda?
Provide a succinct answer. -6.59. In the year 2011, what is the difference between the Employment to population ratio(%) in Mauritius and Employment to population ratio(%) in Nicaragua?
Offer a very short reply. -17.6. In the year 2011, what is the difference between the Employment to population ratio(%) of Mauritius and Employment to population ratio(%) of Uganda?
Provide a short and direct response. -16.4. In the year 2012, what is the difference between the Employment to population ratio(%) in Sub-Saharan Africa (developing only) and Employment to population ratio(%) in Mauritius?
Your response must be concise. 10.99. In the year 2012, what is the difference between the Employment to population ratio(%) of Sub-Saharan Africa (developing only) and Employment to population ratio(%) of Nicaragua?
Ensure brevity in your answer.  -8.31. In the year 2012, what is the difference between the Employment to population ratio(%) of Sub-Saharan Africa (developing only) and Employment to population ratio(%) of Uganda?
Offer a very short reply. -6.31. In the year 2012, what is the difference between the Employment to population ratio(%) of Mauritius and Employment to population ratio(%) of Nicaragua?
Your response must be concise. -19.3. In the year 2012, what is the difference between the Employment to population ratio(%) of Mauritius and Employment to population ratio(%) of Uganda?
Make the answer very short. -17.3. In the year 2012, what is the difference between the Employment to population ratio(%) of Nicaragua and Employment to population ratio(%) of Uganda?
Offer a very short reply. 2. In the year 2013, what is the difference between the Employment to population ratio(%) of Sub-Saharan Africa (developing only) and Employment to population ratio(%) of Mauritius?
Offer a terse response. 8.71. In the year 2013, what is the difference between the Employment to population ratio(%) in Sub-Saharan Africa (developing only) and Employment to population ratio(%) in Nicaragua?
Give a very brief answer. -9.89. In the year 2013, what is the difference between the Employment to population ratio(%) in Sub-Saharan Africa (developing only) and Employment to population ratio(%) in Uganda?
Your answer should be very brief. -6.09. In the year 2013, what is the difference between the Employment to population ratio(%) in Mauritius and Employment to population ratio(%) in Nicaragua?
Your answer should be compact. -18.6. In the year 2013, what is the difference between the Employment to population ratio(%) of Mauritius and Employment to population ratio(%) of Uganda?
Provide a succinct answer. -14.8. In the year 2013, what is the difference between the Employment to population ratio(%) of Nicaragua and Employment to population ratio(%) of Uganda?
Offer a very short reply. 3.8. What is the ratio of the Employment to population ratio(%) in Sub-Saharan Africa (developing only) in 2006 to that in 2007?
Ensure brevity in your answer.  1. What is the ratio of the Employment to population ratio(%) of Mauritius in 2006 to that in 2007?
Ensure brevity in your answer.  1.03. What is the ratio of the Employment to population ratio(%) of Nicaragua in 2006 to that in 2007?
Give a very brief answer. 0.99. What is the ratio of the Employment to population ratio(%) of Sub-Saharan Africa (developing only) in 2006 to that in 2008?
Your response must be concise. 1. What is the ratio of the Employment to population ratio(%) of Mauritius in 2006 to that in 2008?
Ensure brevity in your answer.  1.02. What is the ratio of the Employment to population ratio(%) of Nicaragua in 2006 to that in 2008?
Make the answer very short. 1.01. What is the ratio of the Employment to population ratio(%) in Uganda in 2006 to that in 2008?
Offer a very short reply. 1.01. What is the ratio of the Employment to population ratio(%) in Sub-Saharan Africa (developing only) in 2006 to that in 2009?
Your response must be concise. 1. What is the ratio of the Employment to population ratio(%) of Mauritius in 2006 to that in 2009?
Give a very brief answer. 1.08. What is the ratio of the Employment to population ratio(%) in Nicaragua in 2006 to that in 2009?
Keep it short and to the point. 1.02. What is the ratio of the Employment to population ratio(%) of Uganda in 2006 to that in 2009?
Make the answer very short. 1.02. What is the ratio of the Employment to population ratio(%) in Sub-Saharan Africa (developing only) in 2006 to that in 2010?
Ensure brevity in your answer.  1. What is the ratio of the Employment to population ratio(%) of Mauritius in 2006 to that in 2010?
Keep it short and to the point. 1.1. What is the ratio of the Employment to population ratio(%) of Nicaragua in 2006 to that in 2010?
Your response must be concise. 1.04. What is the ratio of the Employment to population ratio(%) in Uganda in 2006 to that in 2010?
Your response must be concise. 1.03. What is the ratio of the Employment to population ratio(%) of Sub-Saharan Africa (developing only) in 2006 to that in 2011?
Ensure brevity in your answer.  1. What is the ratio of the Employment to population ratio(%) in Mauritius in 2006 to that in 2011?
Provide a succinct answer. 1.07. What is the ratio of the Employment to population ratio(%) of Nicaragua in 2006 to that in 2011?
Provide a succinct answer. 1.03. What is the ratio of the Employment to population ratio(%) in Uganda in 2006 to that in 2011?
Offer a terse response. 1.03. What is the ratio of the Employment to population ratio(%) in Sub-Saharan Africa (developing only) in 2006 to that in 2012?
Provide a succinct answer. 1. What is the ratio of the Employment to population ratio(%) of Mauritius in 2006 to that in 2012?
Ensure brevity in your answer.  1.1. What is the ratio of the Employment to population ratio(%) of Nicaragua in 2006 to that in 2012?
Provide a succinct answer. 1.02. What is the ratio of the Employment to population ratio(%) in Uganda in 2006 to that in 2012?
Your answer should be very brief. 1.03. What is the ratio of the Employment to population ratio(%) of Mauritius in 2006 to that in 2013?
Give a very brief answer. 1.04. What is the ratio of the Employment to population ratio(%) in Nicaragua in 2006 to that in 2013?
Your response must be concise. 0.99. What is the ratio of the Employment to population ratio(%) in Uganda in 2006 to that in 2013?
Provide a succinct answer. 1.04. What is the ratio of the Employment to population ratio(%) of Mauritius in 2007 to that in 2008?
Your answer should be compact. 0.99. What is the ratio of the Employment to population ratio(%) in Nicaragua in 2007 to that in 2008?
Keep it short and to the point. 1.02. What is the ratio of the Employment to population ratio(%) of Uganda in 2007 to that in 2008?
Make the answer very short. 1.02. What is the ratio of the Employment to population ratio(%) in Sub-Saharan Africa (developing only) in 2007 to that in 2009?
Give a very brief answer. 1.01. What is the ratio of the Employment to population ratio(%) in Mauritius in 2007 to that in 2009?
Offer a very short reply. 1.05. What is the ratio of the Employment to population ratio(%) in Nicaragua in 2007 to that in 2009?
Give a very brief answer. 1.03. What is the ratio of the Employment to population ratio(%) in Uganda in 2007 to that in 2009?
Keep it short and to the point. 1.03. What is the ratio of the Employment to population ratio(%) in Mauritius in 2007 to that in 2010?
Give a very brief answer. 1.07. What is the ratio of the Employment to population ratio(%) in Nicaragua in 2007 to that in 2010?
Ensure brevity in your answer.  1.05. What is the ratio of the Employment to population ratio(%) in Uganda in 2007 to that in 2010?
Ensure brevity in your answer.  1.04. What is the ratio of the Employment to population ratio(%) of Sub-Saharan Africa (developing only) in 2007 to that in 2011?
Keep it short and to the point. 1. What is the ratio of the Employment to population ratio(%) in Mauritius in 2007 to that in 2011?
Ensure brevity in your answer.  1.04. What is the ratio of the Employment to population ratio(%) in Nicaragua in 2007 to that in 2011?
Your answer should be compact. 1.04. What is the ratio of the Employment to population ratio(%) of Uganda in 2007 to that in 2011?
Give a very brief answer. 1.04. What is the ratio of the Employment to population ratio(%) of Sub-Saharan Africa (developing only) in 2007 to that in 2012?
Give a very brief answer. 1. What is the ratio of the Employment to population ratio(%) in Mauritius in 2007 to that in 2012?
Ensure brevity in your answer.  1.07. What is the ratio of the Employment to population ratio(%) in Nicaragua in 2007 to that in 2012?
Your response must be concise. 1.03. What is the ratio of the Employment to population ratio(%) in Uganda in 2007 to that in 2012?
Keep it short and to the point. 1.04. What is the ratio of the Employment to population ratio(%) in Mauritius in 2007 to that in 2013?
Offer a very short reply. 1.01. What is the ratio of the Employment to population ratio(%) of Uganda in 2007 to that in 2013?
Keep it short and to the point. 1.04. What is the ratio of the Employment to population ratio(%) of Mauritius in 2008 to that in 2009?
Your answer should be very brief. 1.06. What is the ratio of the Employment to population ratio(%) in Nicaragua in 2008 to that in 2009?
Make the answer very short. 1.01. What is the ratio of the Employment to population ratio(%) in Uganda in 2008 to that in 2009?
Make the answer very short. 1.01. What is the ratio of the Employment to population ratio(%) of Sub-Saharan Africa (developing only) in 2008 to that in 2010?
Provide a succinct answer. 1. What is the ratio of the Employment to population ratio(%) of Mauritius in 2008 to that in 2010?
Your response must be concise. 1.08. What is the ratio of the Employment to population ratio(%) of Uganda in 2008 to that in 2010?
Give a very brief answer. 1.02. What is the ratio of the Employment to population ratio(%) of Sub-Saharan Africa (developing only) in 2008 to that in 2011?
Your answer should be compact. 1. What is the ratio of the Employment to population ratio(%) in Mauritius in 2008 to that in 2011?
Your response must be concise. 1.05. What is the ratio of the Employment to population ratio(%) of Nicaragua in 2008 to that in 2011?
Offer a terse response. 1.02. What is the ratio of the Employment to population ratio(%) in Uganda in 2008 to that in 2011?
Keep it short and to the point. 1.02. What is the ratio of the Employment to population ratio(%) of Mauritius in 2008 to that in 2012?
Provide a short and direct response. 1.08. What is the ratio of the Employment to population ratio(%) in Nicaragua in 2008 to that in 2012?
Your response must be concise. 1.01. What is the ratio of the Employment to population ratio(%) in Uganda in 2008 to that in 2012?
Your response must be concise. 1.03. What is the ratio of the Employment to population ratio(%) of Mauritius in 2008 to that in 2013?
Provide a short and direct response. 1.01. What is the ratio of the Employment to population ratio(%) of Uganda in 2008 to that in 2013?
Keep it short and to the point. 1.03. What is the ratio of the Employment to population ratio(%) of Sub-Saharan Africa (developing only) in 2009 to that in 2010?
Give a very brief answer. 1. What is the ratio of the Employment to population ratio(%) of Mauritius in 2009 to that in 2010?
Offer a terse response. 1.02. What is the ratio of the Employment to population ratio(%) of Nicaragua in 2009 to that in 2010?
Make the answer very short. 1.02. What is the ratio of the Employment to population ratio(%) in Uganda in 2009 to that in 2010?
Keep it short and to the point. 1.01. What is the ratio of the Employment to population ratio(%) in Sub-Saharan Africa (developing only) in 2009 to that in 2011?
Provide a succinct answer. 1. What is the ratio of the Employment to population ratio(%) of Mauritius in 2009 to that in 2011?
Provide a succinct answer. 0.99. What is the ratio of the Employment to population ratio(%) in Nicaragua in 2009 to that in 2011?
Keep it short and to the point. 1.01. What is the ratio of the Employment to population ratio(%) of Mauritius in 2009 to that in 2012?
Ensure brevity in your answer.  1.02. What is the ratio of the Employment to population ratio(%) of Nicaragua in 2009 to that in 2012?
Ensure brevity in your answer.  1. What is the ratio of the Employment to population ratio(%) of Uganda in 2009 to that in 2012?
Make the answer very short. 1.01. What is the ratio of the Employment to population ratio(%) in Mauritius in 2009 to that in 2013?
Give a very brief answer. 0.96. What is the ratio of the Employment to population ratio(%) of Nicaragua in 2009 to that in 2013?
Your response must be concise. 0.97. What is the ratio of the Employment to population ratio(%) of Uganda in 2009 to that in 2013?
Give a very brief answer. 1.01. What is the ratio of the Employment to population ratio(%) in Sub-Saharan Africa (developing only) in 2010 to that in 2011?
Your answer should be very brief. 1. What is the ratio of the Employment to population ratio(%) of Mauritius in 2010 to that in 2011?
Offer a very short reply. 0.97. What is the ratio of the Employment to population ratio(%) in Nicaragua in 2010 to that in 2011?
Give a very brief answer. 0.99. What is the ratio of the Employment to population ratio(%) of Uganda in 2010 to that in 2011?
Offer a very short reply. 1. What is the ratio of the Employment to population ratio(%) in Sub-Saharan Africa (developing only) in 2010 to that in 2012?
Offer a terse response. 1. What is the ratio of the Employment to population ratio(%) in Nicaragua in 2010 to that in 2012?
Offer a terse response. 0.98. What is the ratio of the Employment to population ratio(%) in Uganda in 2010 to that in 2012?
Give a very brief answer. 1.01. What is the ratio of the Employment to population ratio(%) in Mauritius in 2010 to that in 2013?
Offer a very short reply. 0.94. What is the ratio of the Employment to population ratio(%) of Nicaragua in 2010 to that in 2013?
Provide a short and direct response. 0.96. What is the ratio of the Employment to population ratio(%) in Uganda in 2010 to that in 2013?
Offer a terse response. 1.01. What is the ratio of the Employment to population ratio(%) of Sub-Saharan Africa (developing only) in 2011 to that in 2012?
Offer a very short reply. 1. What is the ratio of the Employment to population ratio(%) of Mauritius in 2011 to that in 2012?
Ensure brevity in your answer.  1.03. What is the ratio of the Employment to population ratio(%) of Nicaragua in 2011 to that in 2012?
Give a very brief answer. 0.99. What is the ratio of the Employment to population ratio(%) in Uganda in 2011 to that in 2012?
Your answer should be compact. 1. What is the ratio of the Employment to population ratio(%) of Sub-Saharan Africa (developing only) in 2011 to that in 2013?
Your answer should be compact. 1. What is the ratio of the Employment to population ratio(%) in Mauritius in 2011 to that in 2013?
Provide a short and direct response. 0.97. What is the ratio of the Employment to population ratio(%) in Nicaragua in 2011 to that in 2013?
Make the answer very short. 0.96. What is the ratio of the Employment to population ratio(%) in Uganda in 2011 to that in 2013?
Make the answer very short. 1.01. What is the ratio of the Employment to population ratio(%) of Mauritius in 2012 to that in 2013?
Offer a very short reply. 0.94. What is the ratio of the Employment to population ratio(%) in Nicaragua in 2012 to that in 2013?
Make the answer very short. 0.97. What is the ratio of the Employment to population ratio(%) in Uganda in 2012 to that in 2013?
Your response must be concise. 1. What is the difference between the highest and the second highest Employment to population ratio(%) in Sub-Saharan Africa (developing only)?
Provide a short and direct response. 0. What is the difference between the highest and the second highest Employment to population ratio(%) in Mauritius?
Your answer should be very brief. 1. What is the difference between the highest and the second highest Employment to population ratio(%) of Uganda?
Ensure brevity in your answer.  0.4. What is the difference between the highest and the lowest Employment to population ratio(%) of Sub-Saharan Africa (developing only)?
Provide a short and direct response. 0.33. What is the difference between the highest and the lowest Employment to population ratio(%) of Mauritius?
Give a very brief answer. 4. What is the difference between the highest and the lowest Employment to population ratio(%) in Nicaragua?
Your response must be concise. 2.6. 